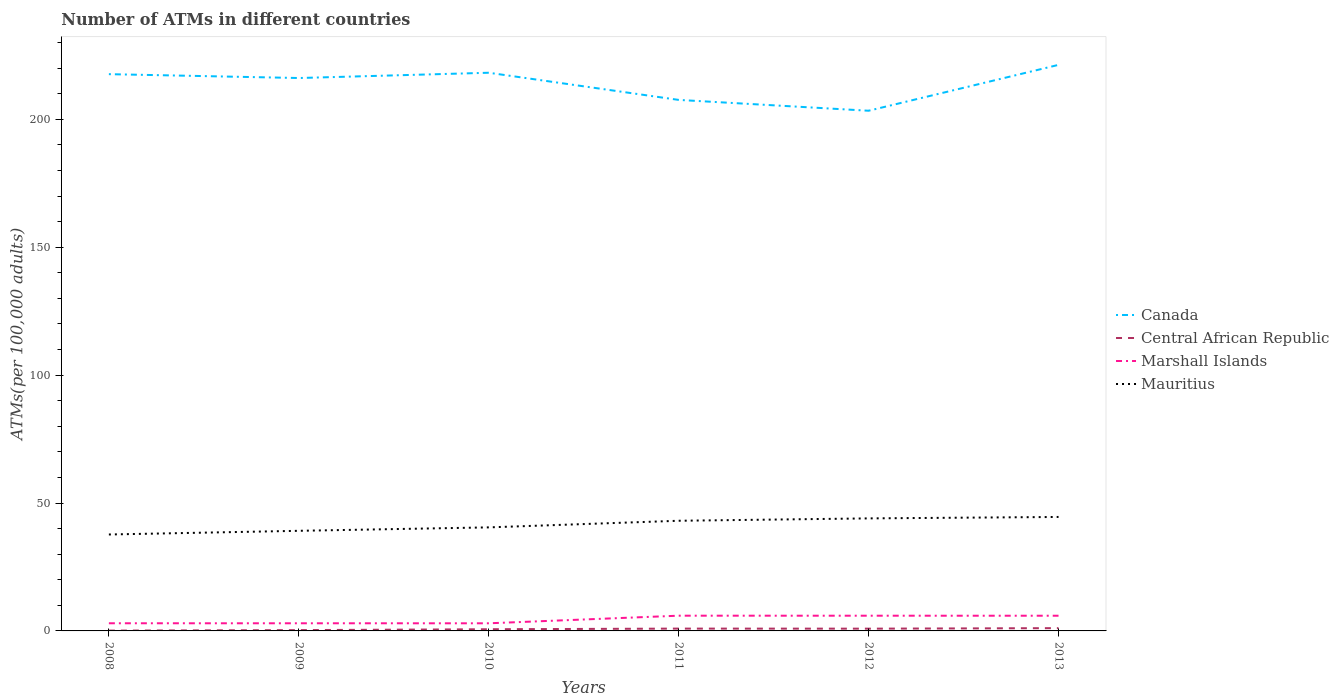Does the line corresponding to Canada intersect with the line corresponding to Marshall Islands?
Offer a terse response. No. Across all years, what is the maximum number of ATMs in Central African Republic?
Ensure brevity in your answer.  0.12. In which year was the number of ATMs in Mauritius maximum?
Keep it short and to the point. 2008. What is the total number of ATMs in Mauritius in the graph?
Your answer should be very brief. -3.93. What is the difference between the highest and the second highest number of ATMs in Canada?
Ensure brevity in your answer.  17.93. What is the difference between the highest and the lowest number of ATMs in Marshall Islands?
Provide a short and direct response. 3. Is the number of ATMs in Marshall Islands strictly greater than the number of ATMs in Canada over the years?
Offer a terse response. Yes. How many lines are there?
Your response must be concise. 4. Are the values on the major ticks of Y-axis written in scientific E-notation?
Your answer should be compact. No. Does the graph contain any zero values?
Provide a short and direct response. No. Does the graph contain grids?
Your response must be concise. No. Where does the legend appear in the graph?
Make the answer very short. Center right. How are the legend labels stacked?
Your answer should be compact. Vertical. What is the title of the graph?
Your answer should be very brief. Number of ATMs in different countries. Does "Peru" appear as one of the legend labels in the graph?
Make the answer very short. No. What is the label or title of the Y-axis?
Provide a succinct answer. ATMs(per 100,0 adults). What is the ATMs(per 100,000 adults) of Canada in 2008?
Provide a succinct answer. 217.63. What is the ATMs(per 100,000 adults) in Central African Republic in 2008?
Offer a terse response. 0.12. What is the ATMs(per 100,000 adults) in Marshall Islands in 2008?
Provide a succinct answer. 2.99. What is the ATMs(per 100,000 adults) of Mauritius in 2008?
Give a very brief answer. 37.69. What is the ATMs(per 100,000 adults) of Canada in 2009?
Give a very brief answer. 216.11. What is the ATMs(per 100,000 adults) in Central African Republic in 2009?
Offer a terse response. 0.32. What is the ATMs(per 100,000 adults) of Marshall Islands in 2009?
Your answer should be very brief. 2.99. What is the ATMs(per 100,000 adults) in Mauritius in 2009?
Make the answer very short. 39.13. What is the ATMs(per 100,000 adults) of Canada in 2010?
Offer a very short reply. 218.18. What is the ATMs(per 100,000 adults) in Central African Republic in 2010?
Offer a very short reply. 0.66. What is the ATMs(per 100,000 adults) of Marshall Islands in 2010?
Provide a short and direct response. 2.98. What is the ATMs(per 100,000 adults) of Mauritius in 2010?
Your response must be concise. 40.47. What is the ATMs(per 100,000 adults) of Canada in 2011?
Keep it short and to the point. 207.56. What is the ATMs(per 100,000 adults) in Central African Republic in 2011?
Give a very brief answer. 0.91. What is the ATMs(per 100,000 adults) of Marshall Islands in 2011?
Give a very brief answer. 5.95. What is the ATMs(per 100,000 adults) of Mauritius in 2011?
Keep it short and to the point. 43.06. What is the ATMs(per 100,000 adults) in Canada in 2012?
Give a very brief answer. 203.33. What is the ATMs(per 100,000 adults) of Central African Republic in 2012?
Keep it short and to the point. 0.88. What is the ATMs(per 100,000 adults) of Marshall Islands in 2012?
Your answer should be compact. 5.95. What is the ATMs(per 100,000 adults) of Mauritius in 2012?
Give a very brief answer. 43.99. What is the ATMs(per 100,000 adults) of Canada in 2013?
Make the answer very short. 221.26. What is the ATMs(per 100,000 adults) of Central African Republic in 2013?
Keep it short and to the point. 1.08. What is the ATMs(per 100,000 adults) in Marshall Islands in 2013?
Keep it short and to the point. 5.94. What is the ATMs(per 100,000 adults) of Mauritius in 2013?
Your response must be concise. 44.55. Across all years, what is the maximum ATMs(per 100,000 adults) in Canada?
Your answer should be compact. 221.26. Across all years, what is the maximum ATMs(per 100,000 adults) of Central African Republic?
Offer a very short reply. 1.08. Across all years, what is the maximum ATMs(per 100,000 adults) of Marshall Islands?
Make the answer very short. 5.95. Across all years, what is the maximum ATMs(per 100,000 adults) of Mauritius?
Your answer should be very brief. 44.55. Across all years, what is the minimum ATMs(per 100,000 adults) in Canada?
Keep it short and to the point. 203.33. Across all years, what is the minimum ATMs(per 100,000 adults) in Central African Republic?
Ensure brevity in your answer.  0.12. Across all years, what is the minimum ATMs(per 100,000 adults) of Marshall Islands?
Keep it short and to the point. 2.98. Across all years, what is the minimum ATMs(per 100,000 adults) of Mauritius?
Your answer should be compact. 37.69. What is the total ATMs(per 100,000 adults) in Canada in the graph?
Keep it short and to the point. 1284.07. What is the total ATMs(per 100,000 adults) in Central African Republic in the graph?
Offer a very short reply. 3.97. What is the total ATMs(per 100,000 adults) in Marshall Islands in the graph?
Your answer should be very brief. 26.8. What is the total ATMs(per 100,000 adults) in Mauritius in the graph?
Keep it short and to the point. 248.89. What is the difference between the ATMs(per 100,000 adults) of Canada in 2008 and that in 2009?
Your answer should be compact. 1.51. What is the difference between the ATMs(per 100,000 adults) of Central African Republic in 2008 and that in 2009?
Provide a succinct answer. -0.2. What is the difference between the ATMs(per 100,000 adults) in Marshall Islands in 2008 and that in 2009?
Keep it short and to the point. 0.01. What is the difference between the ATMs(per 100,000 adults) in Mauritius in 2008 and that in 2009?
Ensure brevity in your answer.  -1.44. What is the difference between the ATMs(per 100,000 adults) in Canada in 2008 and that in 2010?
Provide a short and direct response. -0.55. What is the difference between the ATMs(per 100,000 adults) of Central African Republic in 2008 and that in 2010?
Keep it short and to the point. -0.54. What is the difference between the ATMs(per 100,000 adults) of Marshall Islands in 2008 and that in 2010?
Give a very brief answer. 0.01. What is the difference between the ATMs(per 100,000 adults) in Mauritius in 2008 and that in 2010?
Provide a succinct answer. -2.78. What is the difference between the ATMs(per 100,000 adults) of Canada in 2008 and that in 2011?
Your answer should be very brief. 10.06. What is the difference between the ATMs(per 100,000 adults) in Central African Republic in 2008 and that in 2011?
Your answer should be compact. -0.79. What is the difference between the ATMs(per 100,000 adults) of Marshall Islands in 2008 and that in 2011?
Offer a very short reply. -2.96. What is the difference between the ATMs(per 100,000 adults) in Mauritius in 2008 and that in 2011?
Provide a succinct answer. -5.37. What is the difference between the ATMs(per 100,000 adults) in Canada in 2008 and that in 2012?
Provide a succinct answer. 14.3. What is the difference between the ATMs(per 100,000 adults) in Central African Republic in 2008 and that in 2012?
Ensure brevity in your answer.  -0.76. What is the difference between the ATMs(per 100,000 adults) in Marshall Islands in 2008 and that in 2012?
Give a very brief answer. -2.96. What is the difference between the ATMs(per 100,000 adults) in Mauritius in 2008 and that in 2012?
Give a very brief answer. -6.29. What is the difference between the ATMs(per 100,000 adults) in Canada in 2008 and that in 2013?
Offer a very short reply. -3.63. What is the difference between the ATMs(per 100,000 adults) in Central African Republic in 2008 and that in 2013?
Your response must be concise. -0.96. What is the difference between the ATMs(per 100,000 adults) of Marshall Islands in 2008 and that in 2013?
Make the answer very short. -2.95. What is the difference between the ATMs(per 100,000 adults) of Mauritius in 2008 and that in 2013?
Ensure brevity in your answer.  -6.85. What is the difference between the ATMs(per 100,000 adults) in Canada in 2009 and that in 2010?
Give a very brief answer. -2.06. What is the difference between the ATMs(per 100,000 adults) in Central African Republic in 2009 and that in 2010?
Ensure brevity in your answer.  -0.34. What is the difference between the ATMs(per 100,000 adults) in Marshall Islands in 2009 and that in 2010?
Keep it short and to the point. 0.01. What is the difference between the ATMs(per 100,000 adults) of Mauritius in 2009 and that in 2010?
Keep it short and to the point. -1.34. What is the difference between the ATMs(per 100,000 adults) of Canada in 2009 and that in 2011?
Ensure brevity in your answer.  8.55. What is the difference between the ATMs(per 100,000 adults) of Central African Republic in 2009 and that in 2011?
Ensure brevity in your answer.  -0.59. What is the difference between the ATMs(per 100,000 adults) of Marshall Islands in 2009 and that in 2011?
Your answer should be compact. -2.97. What is the difference between the ATMs(per 100,000 adults) of Mauritius in 2009 and that in 2011?
Provide a short and direct response. -3.93. What is the difference between the ATMs(per 100,000 adults) of Canada in 2009 and that in 2012?
Your answer should be compact. 12.79. What is the difference between the ATMs(per 100,000 adults) in Central African Republic in 2009 and that in 2012?
Your response must be concise. -0.57. What is the difference between the ATMs(per 100,000 adults) of Marshall Islands in 2009 and that in 2012?
Your answer should be very brief. -2.96. What is the difference between the ATMs(per 100,000 adults) in Mauritius in 2009 and that in 2012?
Your answer should be compact. -4.86. What is the difference between the ATMs(per 100,000 adults) of Canada in 2009 and that in 2013?
Provide a short and direct response. -5.15. What is the difference between the ATMs(per 100,000 adults) of Central African Republic in 2009 and that in 2013?
Make the answer very short. -0.76. What is the difference between the ATMs(per 100,000 adults) of Marshall Islands in 2009 and that in 2013?
Make the answer very short. -2.95. What is the difference between the ATMs(per 100,000 adults) in Mauritius in 2009 and that in 2013?
Give a very brief answer. -5.41. What is the difference between the ATMs(per 100,000 adults) in Canada in 2010 and that in 2011?
Provide a short and direct response. 10.61. What is the difference between the ATMs(per 100,000 adults) in Central African Republic in 2010 and that in 2011?
Make the answer very short. -0.25. What is the difference between the ATMs(per 100,000 adults) of Marshall Islands in 2010 and that in 2011?
Provide a short and direct response. -2.97. What is the difference between the ATMs(per 100,000 adults) in Mauritius in 2010 and that in 2011?
Ensure brevity in your answer.  -2.59. What is the difference between the ATMs(per 100,000 adults) of Canada in 2010 and that in 2012?
Offer a terse response. 14.85. What is the difference between the ATMs(per 100,000 adults) in Central African Republic in 2010 and that in 2012?
Provide a short and direct response. -0.23. What is the difference between the ATMs(per 100,000 adults) in Marshall Islands in 2010 and that in 2012?
Give a very brief answer. -2.97. What is the difference between the ATMs(per 100,000 adults) in Mauritius in 2010 and that in 2012?
Ensure brevity in your answer.  -3.52. What is the difference between the ATMs(per 100,000 adults) of Canada in 2010 and that in 2013?
Your answer should be compact. -3.08. What is the difference between the ATMs(per 100,000 adults) in Central African Republic in 2010 and that in 2013?
Provide a short and direct response. -0.42. What is the difference between the ATMs(per 100,000 adults) in Marshall Islands in 2010 and that in 2013?
Give a very brief answer. -2.96. What is the difference between the ATMs(per 100,000 adults) of Mauritius in 2010 and that in 2013?
Your answer should be very brief. -4.07. What is the difference between the ATMs(per 100,000 adults) of Canada in 2011 and that in 2012?
Offer a terse response. 4.24. What is the difference between the ATMs(per 100,000 adults) of Central African Republic in 2011 and that in 2012?
Make the answer very short. 0.02. What is the difference between the ATMs(per 100,000 adults) of Marshall Islands in 2011 and that in 2012?
Keep it short and to the point. 0.01. What is the difference between the ATMs(per 100,000 adults) of Mauritius in 2011 and that in 2012?
Ensure brevity in your answer.  -0.93. What is the difference between the ATMs(per 100,000 adults) in Canada in 2011 and that in 2013?
Keep it short and to the point. -13.7. What is the difference between the ATMs(per 100,000 adults) in Central African Republic in 2011 and that in 2013?
Keep it short and to the point. -0.17. What is the difference between the ATMs(per 100,000 adults) in Marshall Islands in 2011 and that in 2013?
Provide a succinct answer. 0.02. What is the difference between the ATMs(per 100,000 adults) of Mauritius in 2011 and that in 2013?
Offer a terse response. -1.49. What is the difference between the ATMs(per 100,000 adults) in Canada in 2012 and that in 2013?
Provide a short and direct response. -17.93. What is the difference between the ATMs(per 100,000 adults) in Central African Republic in 2012 and that in 2013?
Offer a very short reply. -0.2. What is the difference between the ATMs(per 100,000 adults) in Marshall Islands in 2012 and that in 2013?
Your response must be concise. 0.01. What is the difference between the ATMs(per 100,000 adults) of Mauritius in 2012 and that in 2013?
Provide a short and direct response. -0.56. What is the difference between the ATMs(per 100,000 adults) in Canada in 2008 and the ATMs(per 100,000 adults) in Central African Republic in 2009?
Your answer should be compact. 217.31. What is the difference between the ATMs(per 100,000 adults) of Canada in 2008 and the ATMs(per 100,000 adults) of Marshall Islands in 2009?
Provide a short and direct response. 214.64. What is the difference between the ATMs(per 100,000 adults) in Canada in 2008 and the ATMs(per 100,000 adults) in Mauritius in 2009?
Your answer should be compact. 178.49. What is the difference between the ATMs(per 100,000 adults) in Central African Republic in 2008 and the ATMs(per 100,000 adults) in Marshall Islands in 2009?
Offer a terse response. -2.86. What is the difference between the ATMs(per 100,000 adults) in Central African Republic in 2008 and the ATMs(per 100,000 adults) in Mauritius in 2009?
Provide a succinct answer. -39.01. What is the difference between the ATMs(per 100,000 adults) in Marshall Islands in 2008 and the ATMs(per 100,000 adults) in Mauritius in 2009?
Make the answer very short. -36.14. What is the difference between the ATMs(per 100,000 adults) in Canada in 2008 and the ATMs(per 100,000 adults) in Central African Republic in 2010?
Provide a short and direct response. 216.97. What is the difference between the ATMs(per 100,000 adults) in Canada in 2008 and the ATMs(per 100,000 adults) in Marshall Islands in 2010?
Provide a short and direct response. 214.65. What is the difference between the ATMs(per 100,000 adults) in Canada in 2008 and the ATMs(per 100,000 adults) in Mauritius in 2010?
Provide a succinct answer. 177.15. What is the difference between the ATMs(per 100,000 adults) in Central African Republic in 2008 and the ATMs(per 100,000 adults) in Marshall Islands in 2010?
Your answer should be very brief. -2.86. What is the difference between the ATMs(per 100,000 adults) of Central African Republic in 2008 and the ATMs(per 100,000 adults) of Mauritius in 2010?
Offer a very short reply. -40.35. What is the difference between the ATMs(per 100,000 adults) in Marshall Islands in 2008 and the ATMs(per 100,000 adults) in Mauritius in 2010?
Your response must be concise. -37.48. What is the difference between the ATMs(per 100,000 adults) in Canada in 2008 and the ATMs(per 100,000 adults) in Central African Republic in 2011?
Offer a terse response. 216.72. What is the difference between the ATMs(per 100,000 adults) of Canada in 2008 and the ATMs(per 100,000 adults) of Marshall Islands in 2011?
Offer a very short reply. 211.67. What is the difference between the ATMs(per 100,000 adults) in Canada in 2008 and the ATMs(per 100,000 adults) in Mauritius in 2011?
Ensure brevity in your answer.  174.57. What is the difference between the ATMs(per 100,000 adults) of Central African Republic in 2008 and the ATMs(per 100,000 adults) of Marshall Islands in 2011?
Keep it short and to the point. -5.83. What is the difference between the ATMs(per 100,000 adults) of Central African Republic in 2008 and the ATMs(per 100,000 adults) of Mauritius in 2011?
Make the answer very short. -42.94. What is the difference between the ATMs(per 100,000 adults) in Marshall Islands in 2008 and the ATMs(per 100,000 adults) in Mauritius in 2011?
Your response must be concise. -40.07. What is the difference between the ATMs(per 100,000 adults) of Canada in 2008 and the ATMs(per 100,000 adults) of Central African Republic in 2012?
Offer a very short reply. 216.74. What is the difference between the ATMs(per 100,000 adults) of Canada in 2008 and the ATMs(per 100,000 adults) of Marshall Islands in 2012?
Keep it short and to the point. 211.68. What is the difference between the ATMs(per 100,000 adults) of Canada in 2008 and the ATMs(per 100,000 adults) of Mauritius in 2012?
Keep it short and to the point. 173.64. What is the difference between the ATMs(per 100,000 adults) of Central African Republic in 2008 and the ATMs(per 100,000 adults) of Marshall Islands in 2012?
Your response must be concise. -5.83. What is the difference between the ATMs(per 100,000 adults) in Central African Republic in 2008 and the ATMs(per 100,000 adults) in Mauritius in 2012?
Keep it short and to the point. -43.87. What is the difference between the ATMs(per 100,000 adults) in Marshall Islands in 2008 and the ATMs(per 100,000 adults) in Mauritius in 2012?
Your answer should be compact. -41. What is the difference between the ATMs(per 100,000 adults) in Canada in 2008 and the ATMs(per 100,000 adults) in Central African Republic in 2013?
Ensure brevity in your answer.  216.55. What is the difference between the ATMs(per 100,000 adults) in Canada in 2008 and the ATMs(per 100,000 adults) in Marshall Islands in 2013?
Your answer should be compact. 211.69. What is the difference between the ATMs(per 100,000 adults) in Canada in 2008 and the ATMs(per 100,000 adults) in Mauritius in 2013?
Ensure brevity in your answer.  173.08. What is the difference between the ATMs(per 100,000 adults) in Central African Republic in 2008 and the ATMs(per 100,000 adults) in Marshall Islands in 2013?
Offer a terse response. -5.82. What is the difference between the ATMs(per 100,000 adults) of Central African Republic in 2008 and the ATMs(per 100,000 adults) of Mauritius in 2013?
Make the answer very short. -44.42. What is the difference between the ATMs(per 100,000 adults) in Marshall Islands in 2008 and the ATMs(per 100,000 adults) in Mauritius in 2013?
Your answer should be compact. -41.55. What is the difference between the ATMs(per 100,000 adults) in Canada in 2009 and the ATMs(per 100,000 adults) in Central African Republic in 2010?
Keep it short and to the point. 215.46. What is the difference between the ATMs(per 100,000 adults) of Canada in 2009 and the ATMs(per 100,000 adults) of Marshall Islands in 2010?
Keep it short and to the point. 213.13. What is the difference between the ATMs(per 100,000 adults) of Canada in 2009 and the ATMs(per 100,000 adults) of Mauritius in 2010?
Give a very brief answer. 175.64. What is the difference between the ATMs(per 100,000 adults) in Central African Republic in 2009 and the ATMs(per 100,000 adults) in Marshall Islands in 2010?
Your answer should be compact. -2.66. What is the difference between the ATMs(per 100,000 adults) in Central African Republic in 2009 and the ATMs(per 100,000 adults) in Mauritius in 2010?
Make the answer very short. -40.16. What is the difference between the ATMs(per 100,000 adults) in Marshall Islands in 2009 and the ATMs(per 100,000 adults) in Mauritius in 2010?
Offer a terse response. -37.49. What is the difference between the ATMs(per 100,000 adults) in Canada in 2009 and the ATMs(per 100,000 adults) in Central African Republic in 2011?
Ensure brevity in your answer.  215.21. What is the difference between the ATMs(per 100,000 adults) in Canada in 2009 and the ATMs(per 100,000 adults) in Marshall Islands in 2011?
Give a very brief answer. 210.16. What is the difference between the ATMs(per 100,000 adults) in Canada in 2009 and the ATMs(per 100,000 adults) in Mauritius in 2011?
Ensure brevity in your answer.  173.05. What is the difference between the ATMs(per 100,000 adults) in Central African Republic in 2009 and the ATMs(per 100,000 adults) in Marshall Islands in 2011?
Provide a succinct answer. -5.64. What is the difference between the ATMs(per 100,000 adults) of Central African Republic in 2009 and the ATMs(per 100,000 adults) of Mauritius in 2011?
Offer a very short reply. -42.74. What is the difference between the ATMs(per 100,000 adults) of Marshall Islands in 2009 and the ATMs(per 100,000 adults) of Mauritius in 2011?
Keep it short and to the point. -40.07. What is the difference between the ATMs(per 100,000 adults) of Canada in 2009 and the ATMs(per 100,000 adults) of Central African Republic in 2012?
Ensure brevity in your answer.  215.23. What is the difference between the ATMs(per 100,000 adults) of Canada in 2009 and the ATMs(per 100,000 adults) of Marshall Islands in 2012?
Make the answer very short. 210.17. What is the difference between the ATMs(per 100,000 adults) in Canada in 2009 and the ATMs(per 100,000 adults) in Mauritius in 2012?
Your answer should be compact. 172.13. What is the difference between the ATMs(per 100,000 adults) in Central African Republic in 2009 and the ATMs(per 100,000 adults) in Marshall Islands in 2012?
Offer a terse response. -5.63. What is the difference between the ATMs(per 100,000 adults) of Central African Republic in 2009 and the ATMs(per 100,000 adults) of Mauritius in 2012?
Ensure brevity in your answer.  -43.67. What is the difference between the ATMs(per 100,000 adults) of Marshall Islands in 2009 and the ATMs(per 100,000 adults) of Mauritius in 2012?
Ensure brevity in your answer.  -41. What is the difference between the ATMs(per 100,000 adults) in Canada in 2009 and the ATMs(per 100,000 adults) in Central African Republic in 2013?
Ensure brevity in your answer.  215.03. What is the difference between the ATMs(per 100,000 adults) of Canada in 2009 and the ATMs(per 100,000 adults) of Marshall Islands in 2013?
Ensure brevity in your answer.  210.17. What is the difference between the ATMs(per 100,000 adults) of Canada in 2009 and the ATMs(per 100,000 adults) of Mauritius in 2013?
Offer a very short reply. 171.57. What is the difference between the ATMs(per 100,000 adults) in Central African Republic in 2009 and the ATMs(per 100,000 adults) in Marshall Islands in 2013?
Provide a short and direct response. -5.62. What is the difference between the ATMs(per 100,000 adults) of Central African Republic in 2009 and the ATMs(per 100,000 adults) of Mauritius in 2013?
Offer a very short reply. -44.23. What is the difference between the ATMs(per 100,000 adults) in Marshall Islands in 2009 and the ATMs(per 100,000 adults) in Mauritius in 2013?
Your answer should be very brief. -41.56. What is the difference between the ATMs(per 100,000 adults) in Canada in 2010 and the ATMs(per 100,000 adults) in Central African Republic in 2011?
Your answer should be compact. 217.27. What is the difference between the ATMs(per 100,000 adults) in Canada in 2010 and the ATMs(per 100,000 adults) in Marshall Islands in 2011?
Provide a short and direct response. 212.22. What is the difference between the ATMs(per 100,000 adults) of Canada in 2010 and the ATMs(per 100,000 adults) of Mauritius in 2011?
Your answer should be very brief. 175.12. What is the difference between the ATMs(per 100,000 adults) in Central African Republic in 2010 and the ATMs(per 100,000 adults) in Marshall Islands in 2011?
Provide a succinct answer. -5.3. What is the difference between the ATMs(per 100,000 adults) in Central African Republic in 2010 and the ATMs(per 100,000 adults) in Mauritius in 2011?
Make the answer very short. -42.4. What is the difference between the ATMs(per 100,000 adults) of Marshall Islands in 2010 and the ATMs(per 100,000 adults) of Mauritius in 2011?
Your response must be concise. -40.08. What is the difference between the ATMs(per 100,000 adults) of Canada in 2010 and the ATMs(per 100,000 adults) of Central African Republic in 2012?
Your answer should be compact. 217.29. What is the difference between the ATMs(per 100,000 adults) of Canada in 2010 and the ATMs(per 100,000 adults) of Marshall Islands in 2012?
Ensure brevity in your answer.  212.23. What is the difference between the ATMs(per 100,000 adults) in Canada in 2010 and the ATMs(per 100,000 adults) in Mauritius in 2012?
Provide a short and direct response. 174.19. What is the difference between the ATMs(per 100,000 adults) in Central African Republic in 2010 and the ATMs(per 100,000 adults) in Marshall Islands in 2012?
Ensure brevity in your answer.  -5.29. What is the difference between the ATMs(per 100,000 adults) of Central African Republic in 2010 and the ATMs(per 100,000 adults) of Mauritius in 2012?
Your response must be concise. -43.33. What is the difference between the ATMs(per 100,000 adults) in Marshall Islands in 2010 and the ATMs(per 100,000 adults) in Mauritius in 2012?
Your response must be concise. -41.01. What is the difference between the ATMs(per 100,000 adults) in Canada in 2010 and the ATMs(per 100,000 adults) in Central African Republic in 2013?
Give a very brief answer. 217.1. What is the difference between the ATMs(per 100,000 adults) of Canada in 2010 and the ATMs(per 100,000 adults) of Marshall Islands in 2013?
Your response must be concise. 212.24. What is the difference between the ATMs(per 100,000 adults) in Canada in 2010 and the ATMs(per 100,000 adults) in Mauritius in 2013?
Ensure brevity in your answer.  173.63. What is the difference between the ATMs(per 100,000 adults) in Central African Republic in 2010 and the ATMs(per 100,000 adults) in Marshall Islands in 2013?
Give a very brief answer. -5.28. What is the difference between the ATMs(per 100,000 adults) of Central African Republic in 2010 and the ATMs(per 100,000 adults) of Mauritius in 2013?
Offer a very short reply. -43.89. What is the difference between the ATMs(per 100,000 adults) in Marshall Islands in 2010 and the ATMs(per 100,000 adults) in Mauritius in 2013?
Keep it short and to the point. -41.57. What is the difference between the ATMs(per 100,000 adults) of Canada in 2011 and the ATMs(per 100,000 adults) of Central African Republic in 2012?
Your response must be concise. 206.68. What is the difference between the ATMs(per 100,000 adults) in Canada in 2011 and the ATMs(per 100,000 adults) in Marshall Islands in 2012?
Your answer should be very brief. 201.61. What is the difference between the ATMs(per 100,000 adults) in Canada in 2011 and the ATMs(per 100,000 adults) in Mauritius in 2012?
Your answer should be very brief. 163.57. What is the difference between the ATMs(per 100,000 adults) in Central African Republic in 2011 and the ATMs(per 100,000 adults) in Marshall Islands in 2012?
Offer a very short reply. -5.04. What is the difference between the ATMs(per 100,000 adults) of Central African Republic in 2011 and the ATMs(per 100,000 adults) of Mauritius in 2012?
Your answer should be very brief. -43.08. What is the difference between the ATMs(per 100,000 adults) of Marshall Islands in 2011 and the ATMs(per 100,000 adults) of Mauritius in 2012?
Your answer should be compact. -38.03. What is the difference between the ATMs(per 100,000 adults) of Canada in 2011 and the ATMs(per 100,000 adults) of Central African Republic in 2013?
Your answer should be compact. 206.48. What is the difference between the ATMs(per 100,000 adults) of Canada in 2011 and the ATMs(per 100,000 adults) of Marshall Islands in 2013?
Provide a succinct answer. 201.62. What is the difference between the ATMs(per 100,000 adults) in Canada in 2011 and the ATMs(per 100,000 adults) in Mauritius in 2013?
Your response must be concise. 163.02. What is the difference between the ATMs(per 100,000 adults) of Central African Republic in 2011 and the ATMs(per 100,000 adults) of Marshall Islands in 2013?
Ensure brevity in your answer.  -5.03. What is the difference between the ATMs(per 100,000 adults) of Central African Republic in 2011 and the ATMs(per 100,000 adults) of Mauritius in 2013?
Offer a terse response. -43.64. What is the difference between the ATMs(per 100,000 adults) of Marshall Islands in 2011 and the ATMs(per 100,000 adults) of Mauritius in 2013?
Ensure brevity in your answer.  -38.59. What is the difference between the ATMs(per 100,000 adults) in Canada in 2012 and the ATMs(per 100,000 adults) in Central African Republic in 2013?
Provide a short and direct response. 202.25. What is the difference between the ATMs(per 100,000 adults) of Canada in 2012 and the ATMs(per 100,000 adults) of Marshall Islands in 2013?
Your answer should be very brief. 197.39. What is the difference between the ATMs(per 100,000 adults) in Canada in 2012 and the ATMs(per 100,000 adults) in Mauritius in 2013?
Your answer should be very brief. 158.78. What is the difference between the ATMs(per 100,000 adults) in Central African Republic in 2012 and the ATMs(per 100,000 adults) in Marshall Islands in 2013?
Your response must be concise. -5.05. What is the difference between the ATMs(per 100,000 adults) in Central African Republic in 2012 and the ATMs(per 100,000 adults) in Mauritius in 2013?
Your answer should be compact. -43.66. What is the difference between the ATMs(per 100,000 adults) in Marshall Islands in 2012 and the ATMs(per 100,000 adults) in Mauritius in 2013?
Provide a short and direct response. -38.6. What is the average ATMs(per 100,000 adults) in Canada per year?
Make the answer very short. 214.01. What is the average ATMs(per 100,000 adults) in Central African Republic per year?
Keep it short and to the point. 0.66. What is the average ATMs(per 100,000 adults) of Marshall Islands per year?
Make the answer very short. 4.47. What is the average ATMs(per 100,000 adults) in Mauritius per year?
Your response must be concise. 41.48. In the year 2008, what is the difference between the ATMs(per 100,000 adults) of Canada and ATMs(per 100,000 adults) of Central African Republic?
Give a very brief answer. 217.5. In the year 2008, what is the difference between the ATMs(per 100,000 adults) in Canada and ATMs(per 100,000 adults) in Marshall Islands?
Give a very brief answer. 214.64. In the year 2008, what is the difference between the ATMs(per 100,000 adults) in Canada and ATMs(per 100,000 adults) in Mauritius?
Your response must be concise. 179.93. In the year 2008, what is the difference between the ATMs(per 100,000 adults) in Central African Republic and ATMs(per 100,000 adults) in Marshall Islands?
Offer a very short reply. -2.87. In the year 2008, what is the difference between the ATMs(per 100,000 adults) in Central African Republic and ATMs(per 100,000 adults) in Mauritius?
Offer a terse response. -37.57. In the year 2008, what is the difference between the ATMs(per 100,000 adults) of Marshall Islands and ATMs(per 100,000 adults) of Mauritius?
Ensure brevity in your answer.  -34.7. In the year 2009, what is the difference between the ATMs(per 100,000 adults) in Canada and ATMs(per 100,000 adults) in Central African Republic?
Make the answer very short. 215.8. In the year 2009, what is the difference between the ATMs(per 100,000 adults) of Canada and ATMs(per 100,000 adults) of Marshall Islands?
Provide a succinct answer. 213.13. In the year 2009, what is the difference between the ATMs(per 100,000 adults) of Canada and ATMs(per 100,000 adults) of Mauritius?
Provide a succinct answer. 176.98. In the year 2009, what is the difference between the ATMs(per 100,000 adults) in Central African Republic and ATMs(per 100,000 adults) in Marshall Islands?
Provide a succinct answer. -2.67. In the year 2009, what is the difference between the ATMs(per 100,000 adults) in Central African Republic and ATMs(per 100,000 adults) in Mauritius?
Provide a succinct answer. -38.81. In the year 2009, what is the difference between the ATMs(per 100,000 adults) of Marshall Islands and ATMs(per 100,000 adults) of Mauritius?
Give a very brief answer. -36.15. In the year 2010, what is the difference between the ATMs(per 100,000 adults) of Canada and ATMs(per 100,000 adults) of Central African Republic?
Keep it short and to the point. 217.52. In the year 2010, what is the difference between the ATMs(per 100,000 adults) of Canada and ATMs(per 100,000 adults) of Marshall Islands?
Offer a very short reply. 215.2. In the year 2010, what is the difference between the ATMs(per 100,000 adults) in Canada and ATMs(per 100,000 adults) in Mauritius?
Give a very brief answer. 177.7. In the year 2010, what is the difference between the ATMs(per 100,000 adults) of Central African Republic and ATMs(per 100,000 adults) of Marshall Islands?
Give a very brief answer. -2.32. In the year 2010, what is the difference between the ATMs(per 100,000 adults) in Central African Republic and ATMs(per 100,000 adults) in Mauritius?
Make the answer very short. -39.81. In the year 2010, what is the difference between the ATMs(per 100,000 adults) of Marshall Islands and ATMs(per 100,000 adults) of Mauritius?
Make the answer very short. -37.49. In the year 2011, what is the difference between the ATMs(per 100,000 adults) of Canada and ATMs(per 100,000 adults) of Central African Republic?
Your answer should be very brief. 206.66. In the year 2011, what is the difference between the ATMs(per 100,000 adults) in Canada and ATMs(per 100,000 adults) in Marshall Islands?
Keep it short and to the point. 201.61. In the year 2011, what is the difference between the ATMs(per 100,000 adults) of Canada and ATMs(per 100,000 adults) of Mauritius?
Your answer should be compact. 164.5. In the year 2011, what is the difference between the ATMs(per 100,000 adults) of Central African Republic and ATMs(per 100,000 adults) of Marshall Islands?
Your response must be concise. -5.05. In the year 2011, what is the difference between the ATMs(per 100,000 adults) in Central African Republic and ATMs(per 100,000 adults) in Mauritius?
Provide a short and direct response. -42.15. In the year 2011, what is the difference between the ATMs(per 100,000 adults) in Marshall Islands and ATMs(per 100,000 adults) in Mauritius?
Offer a terse response. -37.11. In the year 2012, what is the difference between the ATMs(per 100,000 adults) in Canada and ATMs(per 100,000 adults) in Central African Republic?
Offer a very short reply. 202.44. In the year 2012, what is the difference between the ATMs(per 100,000 adults) of Canada and ATMs(per 100,000 adults) of Marshall Islands?
Give a very brief answer. 197.38. In the year 2012, what is the difference between the ATMs(per 100,000 adults) in Canada and ATMs(per 100,000 adults) in Mauritius?
Provide a succinct answer. 159.34. In the year 2012, what is the difference between the ATMs(per 100,000 adults) in Central African Republic and ATMs(per 100,000 adults) in Marshall Islands?
Offer a very short reply. -5.06. In the year 2012, what is the difference between the ATMs(per 100,000 adults) in Central African Republic and ATMs(per 100,000 adults) in Mauritius?
Provide a short and direct response. -43.1. In the year 2012, what is the difference between the ATMs(per 100,000 adults) of Marshall Islands and ATMs(per 100,000 adults) of Mauritius?
Your answer should be compact. -38.04. In the year 2013, what is the difference between the ATMs(per 100,000 adults) of Canada and ATMs(per 100,000 adults) of Central African Republic?
Give a very brief answer. 220.18. In the year 2013, what is the difference between the ATMs(per 100,000 adults) in Canada and ATMs(per 100,000 adults) in Marshall Islands?
Your answer should be compact. 215.32. In the year 2013, what is the difference between the ATMs(per 100,000 adults) in Canada and ATMs(per 100,000 adults) in Mauritius?
Your response must be concise. 176.71. In the year 2013, what is the difference between the ATMs(per 100,000 adults) of Central African Republic and ATMs(per 100,000 adults) of Marshall Islands?
Ensure brevity in your answer.  -4.86. In the year 2013, what is the difference between the ATMs(per 100,000 adults) in Central African Republic and ATMs(per 100,000 adults) in Mauritius?
Ensure brevity in your answer.  -43.47. In the year 2013, what is the difference between the ATMs(per 100,000 adults) in Marshall Islands and ATMs(per 100,000 adults) in Mauritius?
Your answer should be very brief. -38.61. What is the ratio of the ATMs(per 100,000 adults) in Canada in 2008 to that in 2009?
Keep it short and to the point. 1.01. What is the ratio of the ATMs(per 100,000 adults) in Central African Republic in 2008 to that in 2009?
Offer a very short reply. 0.38. What is the ratio of the ATMs(per 100,000 adults) of Marshall Islands in 2008 to that in 2009?
Your response must be concise. 1. What is the ratio of the ATMs(per 100,000 adults) of Mauritius in 2008 to that in 2009?
Your answer should be very brief. 0.96. What is the ratio of the ATMs(per 100,000 adults) in Canada in 2008 to that in 2010?
Your response must be concise. 1. What is the ratio of the ATMs(per 100,000 adults) in Central African Republic in 2008 to that in 2010?
Offer a very short reply. 0.19. What is the ratio of the ATMs(per 100,000 adults) in Mauritius in 2008 to that in 2010?
Keep it short and to the point. 0.93. What is the ratio of the ATMs(per 100,000 adults) in Canada in 2008 to that in 2011?
Provide a short and direct response. 1.05. What is the ratio of the ATMs(per 100,000 adults) in Central African Republic in 2008 to that in 2011?
Give a very brief answer. 0.13. What is the ratio of the ATMs(per 100,000 adults) of Marshall Islands in 2008 to that in 2011?
Provide a succinct answer. 0.5. What is the ratio of the ATMs(per 100,000 adults) in Mauritius in 2008 to that in 2011?
Provide a short and direct response. 0.88. What is the ratio of the ATMs(per 100,000 adults) in Canada in 2008 to that in 2012?
Ensure brevity in your answer.  1.07. What is the ratio of the ATMs(per 100,000 adults) in Central African Republic in 2008 to that in 2012?
Your answer should be very brief. 0.14. What is the ratio of the ATMs(per 100,000 adults) of Marshall Islands in 2008 to that in 2012?
Your answer should be compact. 0.5. What is the ratio of the ATMs(per 100,000 adults) in Mauritius in 2008 to that in 2012?
Give a very brief answer. 0.86. What is the ratio of the ATMs(per 100,000 adults) in Canada in 2008 to that in 2013?
Give a very brief answer. 0.98. What is the ratio of the ATMs(per 100,000 adults) of Central African Republic in 2008 to that in 2013?
Your response must be concise. 0.11. What is the ratio of the ATMs(per 100,000 adults) of Marshall Islands in 2008 to that in 2013?
Make the answer very short. 0.5. What is the ratio of the ATMs(per 100,000 adults) of Mauritius in 2008 to that in 2013?
Your response must be concise. 0.85. What is the ratio of the ATMs(per 100,000 adults) in Central African Republic in 2009 to that in 2010?
Provide a succinct answer. 0.48. What is the ratio of the ATMs(per 100,000 adults) in Mauritius in 2009 to that in 2010?
Offer a very short reply. 0.97. What is the ratio of the ATMs(per 100,000 adults) of Canada in 2009 to that in 2011?
Offer a very short reply. 1.04. What is the ratio of the ATMs(per 100,000 adults) in Central African Republic in 2009 to that in 2011?
Offer a very short reply. 0.35. What is the ratio of the ATMs(per 100,000 adults) of Marshall Islands in 2009 to that in 2011?
Provide a succinct answer. 0.5. What is the ratio of the ATMs(per 100,000 adults) in Mauritius in 2009 to that in 2011?
Provide a succinct answer. 0.91. What is the ratio of the ATMs(per 100,000 adults) in Canada in 2009 to that in 2012?
Provide a succinct answer. 1.06. What is the ratio of the ATMs(per 100,000 adults) of Central African Republic in 2009 to that in 2012?
Your answer should be very brief. 0.36. What is the ratio of the ATMs(per 100,000 adults) in Marshall Islands in 2009 to that in 2012?
Your answer should be very brief. 0.5. What is the ratio of the ATMs(per 100,000 adults) of Mauritius in 2009 to that in 2012?
Keep it short and to the point. 0.89. What is the ratio of the ATMs(per 100,000 adults) in Canada in 2009 to that in 2013?
Keep it short and to the point. 0.98. What is the ratio of the ATMs(per 100,000 adults) of Central African Republic in 2009 to that in 2013?
Your answer should be compact. 0.29. What is the ratio of the ATMs(per 100,000 adults) of Marshall Islands in 2009 to that in 2013?
Ensure brevity in your answer.  0.5. What is the ratio of the ATMs(per 100,000 adults) of Mauritius in 2009 to that in 2013?
Your answer should be very brief. 0.88. What is the ratio of the ATMs(per 100,000 adults) in Canada in 2010 to that in 2011?
Offer a very short reply. 1.05. What is the ratio of the ATMs(per 100,000 adults) in Central African Republic in 2010 to that in 2011?
Provide a succinct answer. 0.73. What is the ratio of the ATMs(per 100,000 adults) of Marshall Islands in 2010 to that in 2011?
Make the answer very short. 0.5. What is the ratio of the ATMs(per 100,000 adults) of Mauritius in 2010 to that in 2011?
Your response must be concise. 0.94. What is the ratio of the ATMs(per 100,000 adults) of Canada in 2010 to that in 2012?
Keep it short and to the point. 1.07. What is the ratio of the ATMs(per 100,000 adults) of Central African Republic in 2010 to that in 2012?
Provide a succinct answer. 0.74. What is the ratio of the ATMs(per 100,000 adults) in Marshall Islands in 2010 to that in 2012?
Give a very brief answer. 0.5. What is the ratio of the ATMs(per 100,000 adults) in Mauritius in 2010 to that in 2012?
Your answer should be very brief. 0.92. What is the ratio of the ATMs(per 100,000 adults) of Canada in 2010 to that in 2013?
Give a very brief answer. 0.99. What is the ratio of the ATMs(per 100,000 adults) of Central African Republic in 2010 to that in 2013?
Offer a very short reply. 0.61. What is the ratio of the ATMs(per 100,000 adults) in Marshall Islands in 2010 to that in 2013?
Your answer should be compact. 0.5. What is the ratio of the ATMs(per 100,000 adults) of Mauritius in 2010 to that in 2013?
Your answer should be compact. 0.91. What is the ratio of the ATMs(per 100,000 adults) in Canada in 2011 to that in 2012?
Ensure brevity in your answer.  1.02. What is the ratio of the ATMs(per 100,000 adults) of Central African Republic in 2011 to that in 2012?
Give a very brief answer. 1.03. What is the ratio of the ATMs(per 100,000 adults) of Mauritius in 2011 to that in 2012?
Give a very brief answer. 0.98. What is the ratio of the ATMs(per 100,000 adults) of Canada in 2011 to that in 2013?
Your answer should be very brief. 0.94. What is the ratio of the ATMs(per 100,000 adults) in Central African Republic in 2011 to that in 2013?
Your response must be concise. 0.84. What is the ratio of the ATMs(per 100,000 adults) in Mauritius in 2011 to that in 2013?
Your response must be concise. 0.97. What is the ratio of the ATMs(per 100,000 adults) in Canada in 2012 to that in 2013?
Provide a short and direct response. 0.92. What is the ratio of the ATMs(per 100,000 adults) in Central African Republic in 2012 to that in 2013?
Keep it short and to the point. 0.82. What is the ratio of the ATMs(per 100,000 adults) of Marshall Islands in 2012 to that in 2013?
Give a very brief answer. 1. What is the ratio of the ATMs(per 100,000 adults) of Mauritius in 2012 to that in 2013?
Ensure brevity in your answer.  0.99. What is the difference between the highest and the second highest ATMs(per 100,000 adults) in Canada?
Offer a terse response. 3.08. What is the difference between the highest and the second highest ATMs(per 100,000 adults) in Central African Republic?
Your response must be concise. 0.17. What is the difference between the highest and the second highest ATMs(per 100,000 adults) in Marshall Islands?
Your answer should be very brief. 0.01. What is the difference between the highest and the second highest ATMs(per 100,000 adults) of Mauritius?
Keep it short and to the point. 0.56. What is the difference between the highest and the lowest ATMs(per 100,000 adults) in Canada?
Your answer should be very brief. 17.93. What is the difference between the highest and the lowest ATMs(per 100,000 adults) of Central African Republic?
Give a very brief answer. 0.96. What is the difference between the highest and the lowest ATMs(per 100,000 adults) of Marshall Islands?
Provide a short and direct response. 2.97. What is the difference between the highest and the lowest ATMs(per 100,000 adults) of Mauritius?
Give a very brief answer. 6.85. 